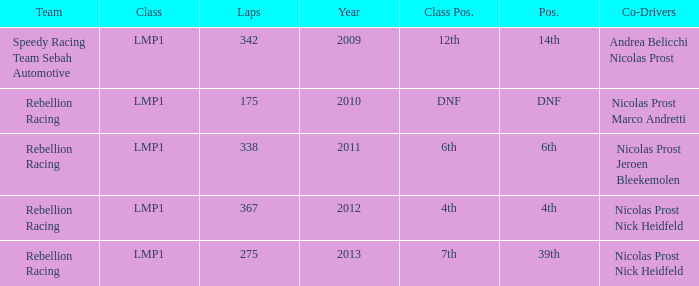What was the class position of the team that was in the 4th position? 4th. 